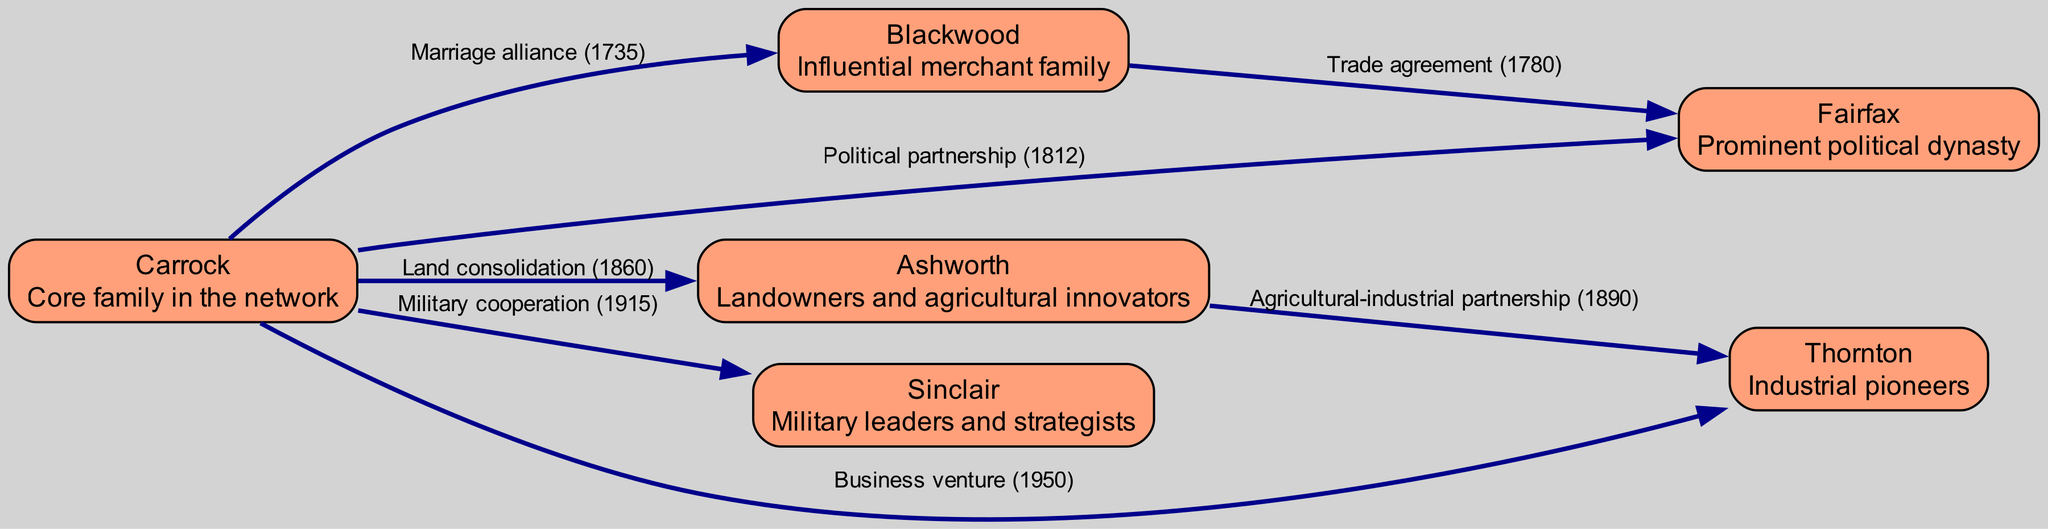What is the core family in the network? The diagram identifies "Carrock" as the central family, which is explicitly labeled as the "Core family in the network."
Answer: Carrock How many families are shown in the diagram? By counting the nodes in the diagram, we see there are six distinct families listed: Carrock, Blackwood, Fairfax, Ashworth, Sinclair, and Thornton.
Answer: 6 What type of relationship exists between Carrock and Blackwood? The edge connecting Carrock and Blackwood is labeled "Marriage alliance (1735)," indicating this specific type of relationship.
Answer: Marriage alliance Which year was the political partnership between Carrock and Fairfax established? The edge connecting these two families is labeled with "Political partnership (1812)," showing the specific year of this event.
Answer: 1812 What is the relationship between Ashworth and Thornton? They are connected by an edge labeled "Agricultural-industrial partnership (1890)," indicating the nature of this relationship.
Answer: Agricultural-industrial partnership Which family is connected to Carrock through military cooperation? The edge connecting Carrock to Sinclair is labeled "Military cooperation (1915)," revealing the relationship type with this family.
Answer: Sinclair How many edges are connected to the Carrock family? Counting the edges originating from Carrock, there are five connections: to Blackwood, Fairfax, Ashworth, Sinclair, and Thornton.
Answer: 5 What significant event links Blackwood and Fairfax? The edge between these two families is labeled "Trade agreement (1780)," indicating a notable relationship event.
Answer: Trade agreement Which family is identified as industrial pioneers in the diagram? The node for Thornton describes it as "Industrial pioneers," making it clear which family holds this distinction.
Answer: Thornton 